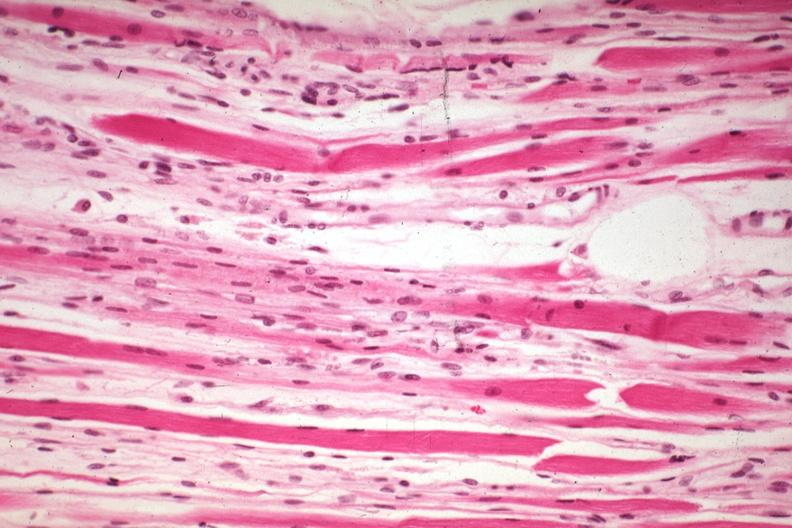s high excellent steroid induced atrophy?
Answer the question using a single word or phrase. Yes 